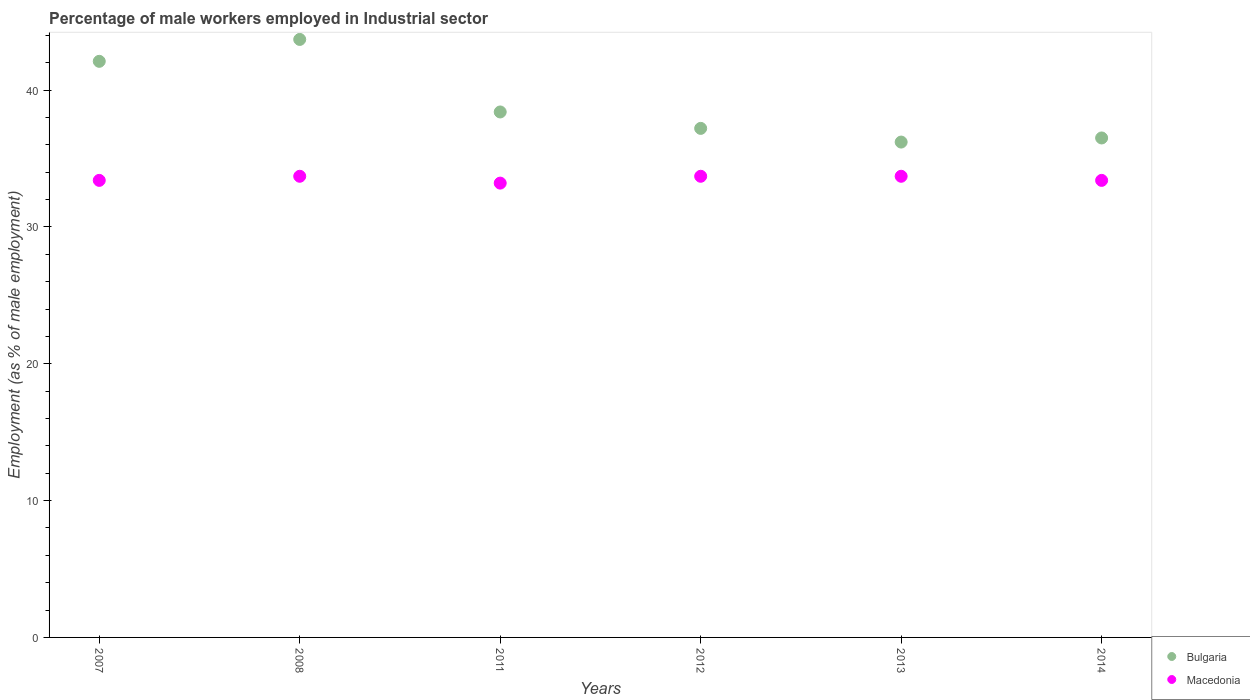How many different coloured dotlines are there?
Your answer should be compact. 2. Is the number of dotlines equal to the number of legend labels?
Ensure brevity in your answer.  Yes. What is the percentage of male workers employed in Industrial sector in Macedonia in 2012?
Your response must be concise. 33.7. Across all years, what is the maximum percentage of male workers employed in Industrial sector in Macedonia?
Offer a very short reply. 33.7. Across all years, what is the minimum percentage of male workers employed in Industrial sector in Macedonia?
Ensure brevity in your answer.  33.2. In which year was the percentage of male workers employed in Industrial sector in Bulgaria maximum?
Give a very brief answer. 2008. In which year was the percentage of male workers employed in Industrial sector in Macedonia minimum?
Provide a short and direct response. 2011. What is the total percentage of male workers employed in Industrial sector in Macedonia in the graph?
Make the answer very short. 201.1. What is the difference between the percentage of male workers employed in Industrial sector in Bulgaria in 2007 and that in 2011?
Your answer should be very brief. 3.7. What is the difference between the percentage of male workers employed in Industrial sector in Bulgaria in 2013 and the percentage of male workers employed in Industrial sector in Macedonia in 2014?
Offer a very short reply. 2.8. What is the average percentage of male workers employed in Industrial sector in Macedonia per year?
Make the answer very short. 33.52. In the year 2014, what is the difference between the percentage of male workers employed in Industrial sector in Macedonia and percentage of male workers employed in Industrial sector in Bulgaria?
Your response must be concise. -3.1. In how many years, is the percentage of male workers employed in Industrial sector in Bulgaria greater than 28 %?
Provide a succinct answer. 6. Is the difference between the percentage of male workers employed in Industrial sector in Macedonia in 2007 and 2013 greater than the difference between the percentage of male workers employed in Industrial sector in Bulgaria in 2007 and 2013?
Make the answer very short. No. What is the difference between the highest and the second highest percentage of male workers employed in Industrial sector in Macedonia?
Offer a terse response. 0. In how many years, is the percentage of male workers employed in Industrial sector in Macedonia greater than the average percentage of male workers employed in Industrial sector in Macedonia taken over all years?
Offer a very short reply. 3. Does the percentage of male workers employed in Industrial sector in Bulgaria monotonically increase over the years?
Offer a very short reply. No. Are the values on the major ticks of Y-axis written in scientific E-notation?
Provide a short and direct response. No. Does the graph contain any zero values?
Offer a very short reply. No. Does the graph contain grids?
Offer a very short reply. No. What is the title of the graph?
Give a very brief answer. Percentage of male workers employed in Industrial sector. Does "Mozambique" appear as one of the legend labels in the graph?
Offer a very short reply. No. What is the label or title of the X-axis?
Give a very brief answer. Years. What is the label or title of the Y-axis?
Keep it short and to the point. Employment (as % of male employment). What is the Employment (as % of male employment) of Bulgaria in 2007?
Provide a succinct answer. 42.1. What is the Employment (as % of male employment) of Macedonia in 2007?
Your response must be concise. 33.4. What is the Employment (as % of male employment) of Bulgaria in 2008?
Keep it short and to the point. 43.7. What is the Employment (as % of male employment) of Macedonia in 2008?
Make the answer very short. 33.7. What is the Employment (as % of male employment) in Bulgaria in 2011?
Give a very brief answer. 38.4. What is the Employment (as % of male employment) of Macedonia in 2011?
Offer a very short reply. 33.2. What is the Employment (as % of male employment) of Bulgaria in 2012?
Make the answer very short. 37.2. What is the Employment (as % of male employment) of Macedonia in 2012?
Provide a short and direct response. 33.7. What is the Employment (as % of male employment) in Bulgaria in 2013?
Your answer should be very brief. 36.2. What is the Employment (as % of male employment) in Macedonia in 2013?
Your answer should be compact. 33.7. What is the Employment (as % of male employment) in Bulgaria in 2014?
Keep it short and to the point. 36.5. What is the Employment (as % of male employment) of Macedonia in 2014?
Your answer should be very brief. 33.4. Across all years, what is the maximum Employment (as % of male employment) in Bulgaria?
Your answer should be compact. 43.7. Across all years, what is the maximum Employment (as % of male employment) in Macedonia?
Your answer should be compact. 33.7. Across all years, what is the minimum Employment (as % of male employment) in Bulgaria?
Make the answer very short. 36.2. Across all years, what is the minimum Employment (as % of male employment) in Macedonia?
Ensure brevity in your answer.  33.2. What is the total Employment (as % of male employment) of Bulgaria in the graph?
Your answer should be very brief. 234.1. What is the total Employment (as % of male employment) in Macedonia in the graph?
Your answer should be very brief. 201.1. What is the difference between the Employment (as % of male employment) in Bulgaria in 2007 and that in 2011?
Your answer should be very brief. 3.7. What is the difference between the Employment (as % of male employment) in Bulgaria in 2007 and that in 2012?
Provide a succinct answer. 4.9. What is the difference between the Employment (as % of male employment) in Macedonia in 2007 and that in 2012?
Provide a succinct answer. -0.3. What is the difference between the Employment (as % of male employment) of Bulgaria in 2007 and that in 2013?
Keep it short and to the point. 5.9. What is the difference between the Employment (as % of male employment) of Macedonia in 2007 and that in 2013?
Offer a terse response. -0.3. What is the difference between the Employment (as % of male employment) in Bulgaria in 2007 and that in 2014?
Your response must be concise. 5.6. What is the difference between the Employment (as % of male employment) in Macedonia in 2007 and that in 2014?
Offer a terse response. 0. What is the difference between the Employment (as % of male employment) of Bulgaria in 2008 and that in 2011?
Give a very brief answer. 5.3. What is the difference between the Employment (as % of male employment) in Macedonia in 2008 and that in 2011?
Your answer should be compact. 0.5. What is the difference between the Employment (as % of male employment) in Bulgaria in 2008 and that in 2012?
Make the answer very short. 6.5. What is the difference between the Employment (as % of male employment) in Bulgaria in 2008 and that in 2013?
Provide a short and direct response. 7.5. What is the difference between the Employment (as % of male employment) of Bulgaria in 2008 and that in 2014?
Offer a very short reply. 7.2. What is the difference between the Employment (as % of male employment) of Macedonia in 2008 and that in 2014?
Offer a terse response. 0.3. What is the difference between the Employment (as % of male employment) in Bulgaria in 2012 and that in 2014?
Make the answer very short. 0.7. What is the difference between the Employment (as % of male employment) of Bulgaria in 2007 and the Employment (as % of male employment) of Macedonia in 2008?
Your answer should be very brief. 8.4. What is the difference between the Employment (as % of male employment) of Bulgaria in 2007 and the Employment (as % of male employment) of Macedonia in 2011?
Your answer should be very brief. 8.9. What is the difference between the Employment (as % of male employment) of Bulgaria in 2008 and the Employment (as % of male employment) of Macedonia in 2011?
Keep it short and to the point. 10.5. What is the difference between the Employment (as % of male employment) of Bulgaria in 2008 and the Employment (as % of male employment) of Macedonia in 2012?
Keep it short and to the point. 10. What is the difference between the Employment (as % of male employment) in Bulgaria in 2008 and the Employment (as % of male employment) in Macedonia in 2013?
Provide a short and direct response. 10. What is the difference between the Employment (as % of male employment) in Bulgaria in 2008 and the Employment (as % of male employment) in Macedonia in 2014?
Give a very brief answer. 10.3. What is the difference between the Employment (as % of male employment) in Bulgaria in 2011 and the Employment (as % of male employment) in Macedonia in 2012?
Give a very brief answer. 4.7. What is the difference between the Employment (as % of male employment) of Bulgaria in 2011 and the Employment (as % of male employment) of Macedonia in 2013?
Your answer should be compact. 4.7. What is the difference between the Employment (as % of male employment) in Bulgaria in 2011 and the Employment (as % of male employment) in Macedonia in 2014?
Ensure brevity in your answer.  5. What is the difference between the Employment (as % of male employment) of Bulgaria in 2013 and the Employment (as % of male employment) of Macedonia in 2014?
Offer a terse response. 2.8. What is the average Employment (as % of male employment) in Bulgaria per year?
Ensure brevity in your answer.  39.02. What is the average Employment (as % of male employment) in Macedonia per year?
Ensure brevity in your answer.  33.52. In the year 2007, what is the difference between the Employment (as % of male employment) of Bulgaria and Employment (as % of male employment) of Macedonia?
Provide a short and direct response. 8.7. In the year 2008, what is the difference between the Employment (as % of male employment) in Bulgaria and Employment (as % of male employment) in Macedonia?
Ensure brevity in your answer.  10. In the year 2011, what is the difference between the Employment (as % of male employment) in Bulgaria and Employment (as % of male employment) in Macedonia?
Provide a short and direct response. 5.2. In the year 2012, what is the difference between the Employment (as % of male employment) in Bulgaria and Employment (as % of male employment) in Macedonia?
Your answer should be compact. 3.5. In the year 2013, what is the difference between the Employment (as % of male employment) in Bulgaria and Employment (as % of male employment) in Macedonia?
Provide a succinct answer. 2.5. In the year 2014, what is the difference between the Employment (as % of male employment) of Bulgaria and Employment (as % of male employment) of Macedonia?
Offer a terse response. 3.1. What is the ratio of the Employment (as % of male employment) of Bulgaria in 2007 to that in 2008?
Your answer should be very brief. 0.96. What is the ratio of the Employment (as % of male employment) in Macedonia in 2007 to that in 2008?
Provide a short and direct response. 0.99. What is the ratio of the Employment (as % of male employment) of Bulgaria in 2007 to that in 2011?
Offer a terse response. 1.1. What is the ratio of the Employment (as % of male employment) in Macedonia in 2007 to that in 2011?
Offer a very short reply. 1.01. What is the ratio of the Employment (as % of male employment) of Bulgaria in 2007 to that in 2012?
Give a very brief answer. 1.13. What is the ratio of the Employment (as % of male employment) in Bulgaria in 2007 to that in 2013?
Your answer should be compact. 1.16. What is the ratio of the Employment (as % of male employment) of Macedonia in 2007 to that in 2013?
Your response must be concise. 0.99. What is the ratio of the Employment (as % of male employment) of Bulgaria in 2007 to that in 2014?
Provide a succinct answer. 1.15. What is the ratio of the Employment (as % of male employment) of Bulgaria in 2008 to that in 2011?
Give a very brief answer. 1.14. What is the ratio of the Employment (as % of male employment) of Macedonia in 2008 to that in 2011?
Your answer should be very brief. 1.02. What is the ratio of the Employment (as % of male employment) in Bulgaria in 2008 to that in 2012?
Offer a very short reply. 1.17. What is the ratio of the Employment (as % of male employment) of Bulgaria in 2008 to that in 2013?
Keep it short and to the point. 1.21. What is the ratio of the Employment (as % of male employment) of Bulgaria in 2008 to that in 2014?
Keep it short and to the point. 1.2. What is the ratio of the Employment (as % of male employment) in Macedonia in 2008 to that in 2014?
Provide a short and direct response. 1.01. What is the ratio of the Employment (as % of male employment) of Bulgaria in 2011 to that in 2012?
Make the answer very short. 1.03. What is the ratio of the Employment (as % of male employment) in Macedonia in 2011 to that in 2012?
Your answer should be compact. 0.99. What is the ratio of the Employment (as % of male employment) of Bulgaria in 2011 to that in 2013?
Make the answer very short. 1.06. What is the ratio of the Employment (as % of male employment) in Macedonia in 2011 to that in 2013?
Your answer should be compact. 0.99. What is the ratio of the Employment (as % of male employment) of Bulgaria in 2011 to that in 2014?
Ensure brevity in your answer.  1.05. What is the ratio of the Employment (as % of male employment) in Bulgaria in 2012 to that in 2013?
Your response must be concise. 1.03. What is the ratio of the Employment (as % of male employment) of Macedonia in 2012 to that in 2013?
Your response must be concise. 1. What is the ratio of the Employment (as % of male employment) of Bulgaria in 2012 to that in 2014?
Your answer should be very brief. 1.02. What is the ratio of the Employment (as % of male employment) in Macedonia in 2012 to that in 2014?
Offer a terse response. 1.01. What is the ratio of the Employment (as % of male employment) in Bulgaria in 2013 to that in 2014?
Keep it short and to the point. 0.99. What is the ratio of the Employment (as % of male employment) of Macedonia in 2013 to that in 2014?
Offer a very short reply. 1.01. What is the difference between the highest and the second highest Employment (as % of male employment) in Bulgaria?
Offer a terse response. 1.6. What is the difference between the highest and the lowest Employment (as % of male employment) in Bulgaria?
Offer a very short reply. 7.5. 